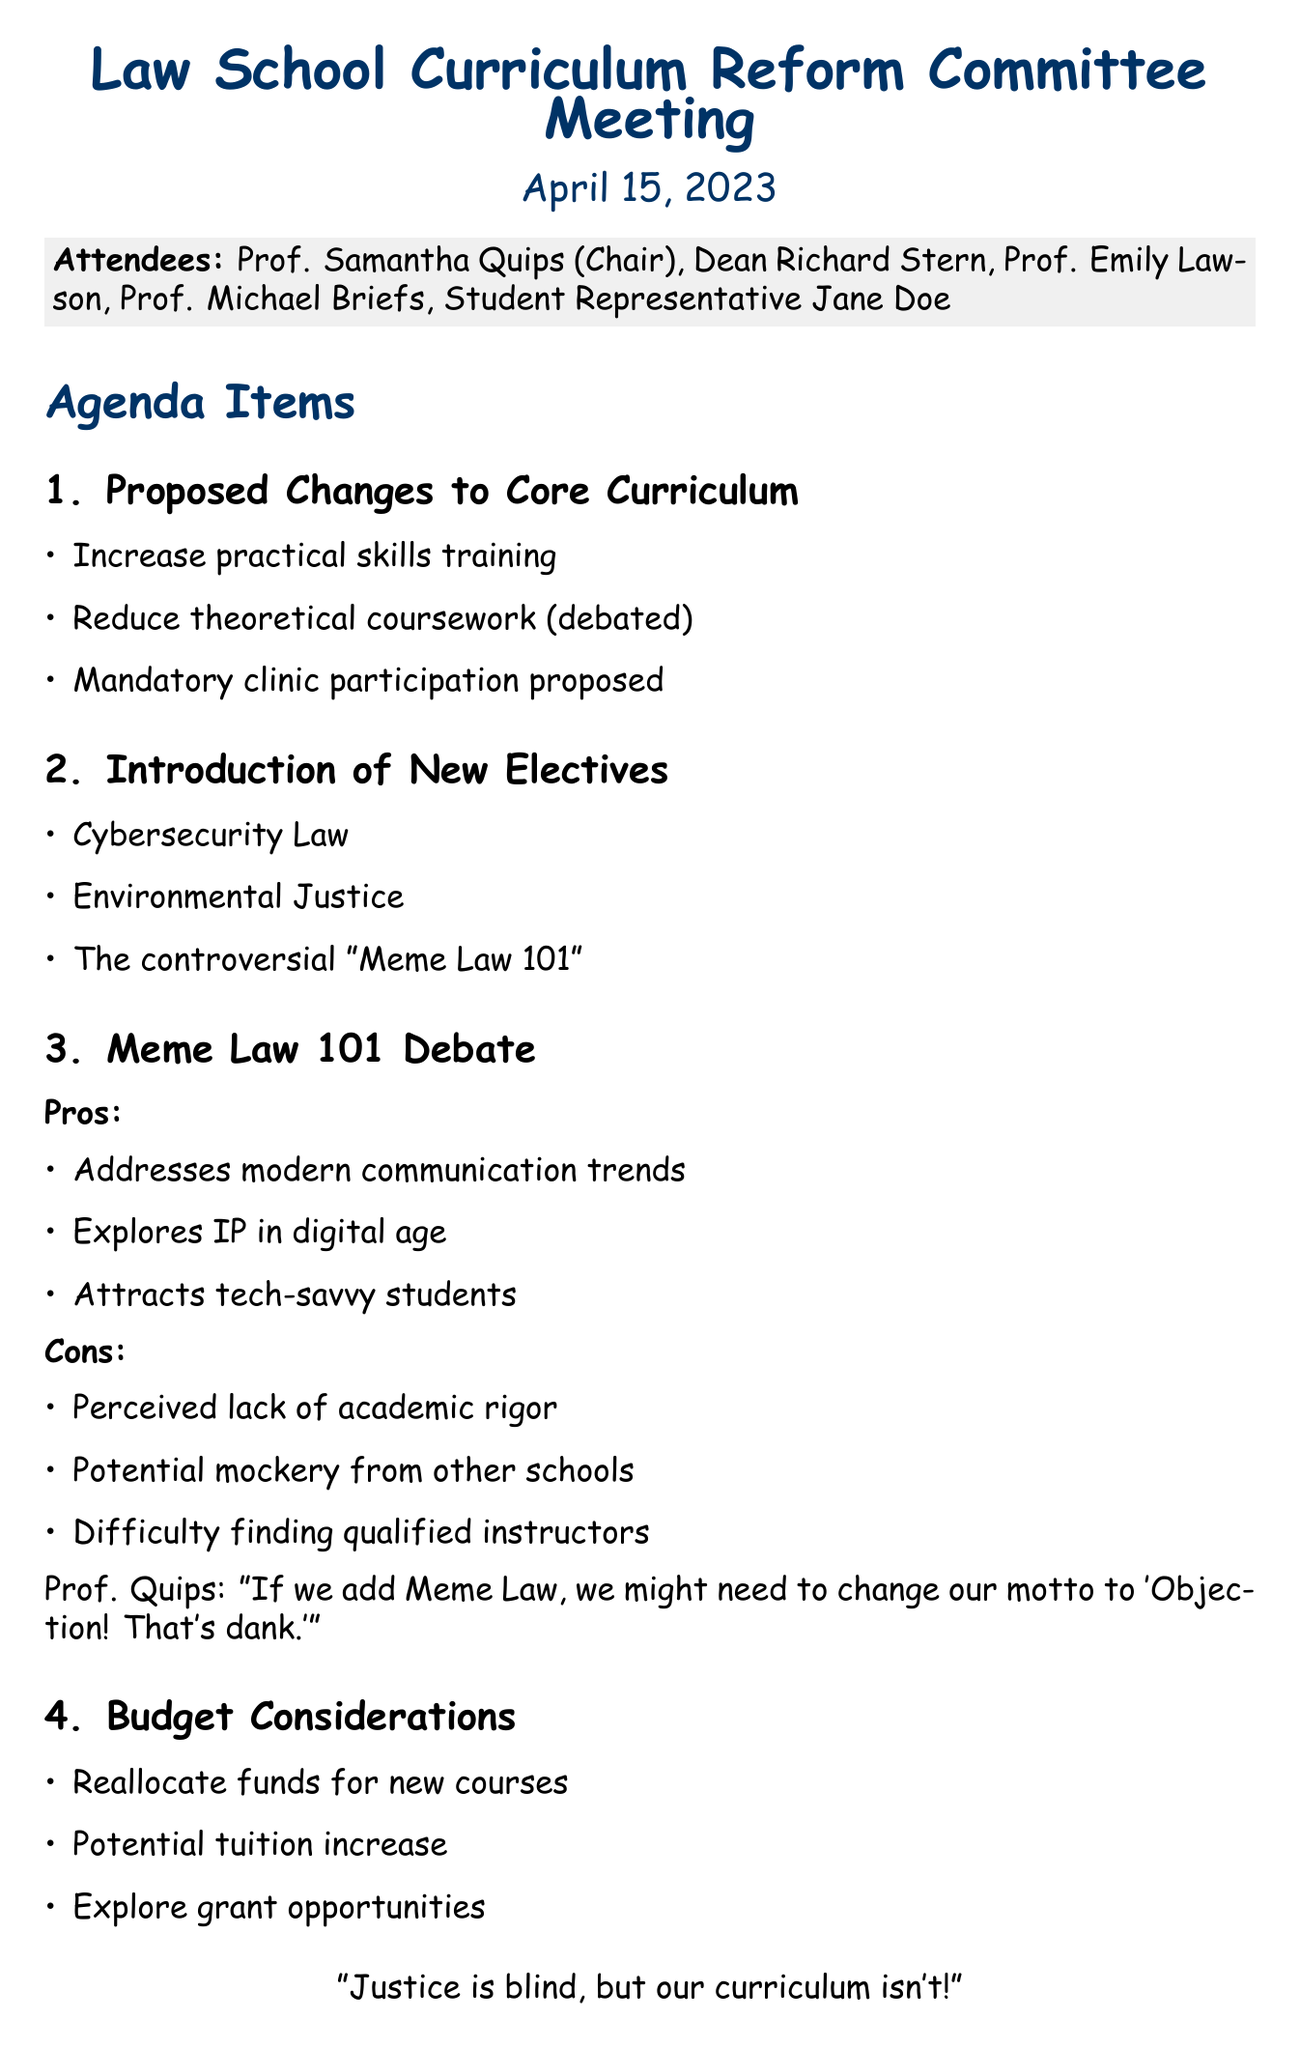what is the meeting title? The meeting title is stated at the beginning of the document.
Answer: Law School Curriculum Reform Committee Meeting who is the chair of the committee? The chair of the committee is mentioned in the list of attendees.
Answer: Prof. Samantha Quips what is the date of the meeting? The date is prominently displayed in the document.
Answer: April 15, 2023 what is one of the proposed changes to the core curriculum? The document lists specific changes proposed during the meeting.
Answer: Mandatory clinic participation what are the pros of adding "Meme Law 101"? The pros are outlined under the debate section for "Meme Law 101."
Answer: Addresses modern communication trends what is a con of adding "Meme Law 101"? The cons are detailed in the same debate section.
Answer: Perceived lack of academic rigor when is the follow-up meeting scheduled? The follow-up meeting date is specified in the next steps section.
Answer: May 1, 2023 who needs to draft the formal proposal for curriculum changes? The action items in the document specify who is responsible for the proposal.
Answer: Prof. Quips what is the purpose of the meeting? The overall purpose can be inferred from the agenda items discussed in the document.
Answer: Curriculum reform 